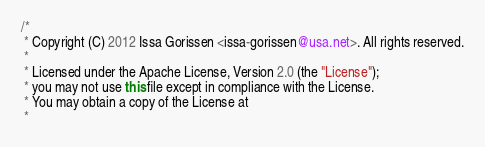Convert code to text. <code><loc_0><loc_0><loc_500><loc_500><_Java_>/*
 * Copyright (C) 2012 Issa Gorissen <issa-gorissen@usa.net>. All rights reserved.
 *
 * Licensed under the Apache License, Version 2.0 (the "License");
 * you may not use this file except in compliance with the License.
 * You may obtain a copy of the License at
 *</code> 